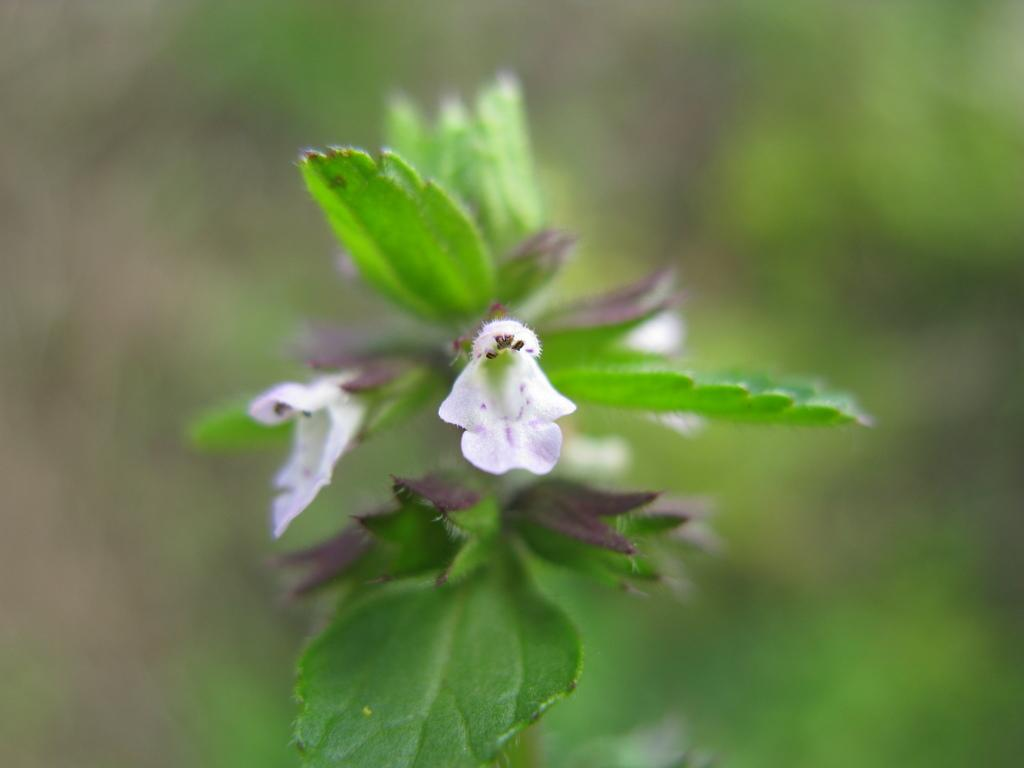What types of plants can be seen in the foreground of the picture? There are leaves and flowers in the foreground of the picture. Can you describe the background of the image? The background of the image is blurred. What type of cap is being worn by the flower in the image? There is no cap present in the image, as it features leaves and flowers in the foreground. What flavor of eggnog is being served in the image? There is no eggnog present in the image; it features leaves and flowers in the foreground. 